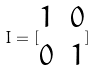<formula> <loc_0><loc_0><loc_500><loc_500>I = [ \begin{matrix} 1 & 0 \\ 0 & 1 \end{matrix} ]</formula> 